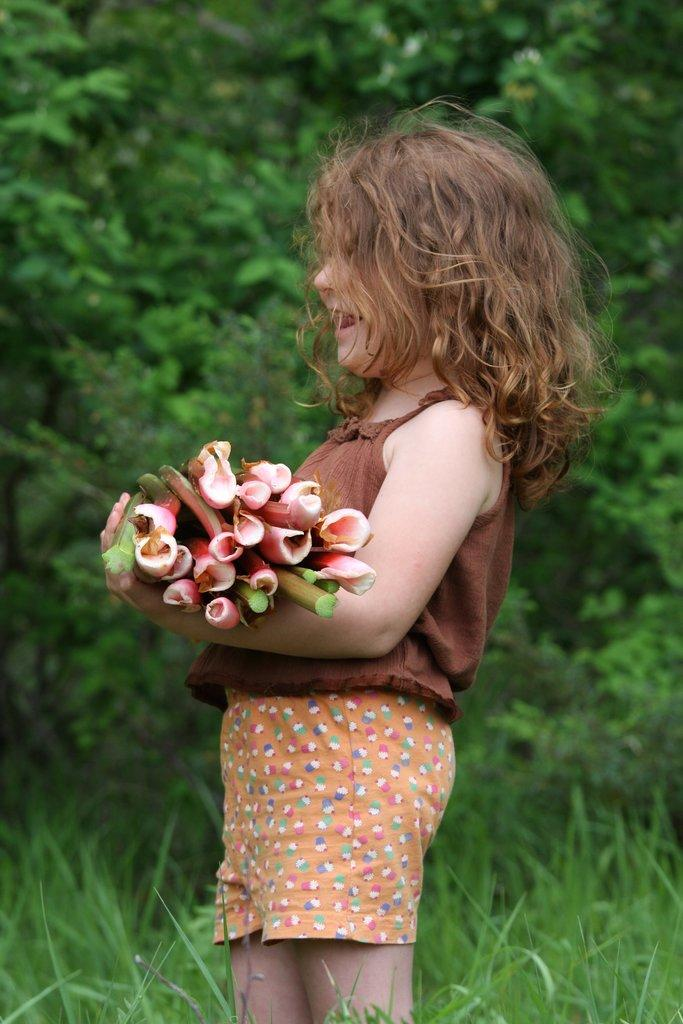Who is the main subject in the image? There is a little girl in the image. Can you describe the girl's appearance? The girl has curly hair. What is the girl holding in her hand? The girl is holding a bunch of flowers in her hand. What can be seen in the background of the image? The background of the image is green, and there are trees visible. What type of vegetation is at the bottom of the image? Grass is visible at the bottom of the image. How many leather islands can be seen in the image? There are no leather islands present in the image; it features a little girl holding flowers against a green background with trees and grass. 